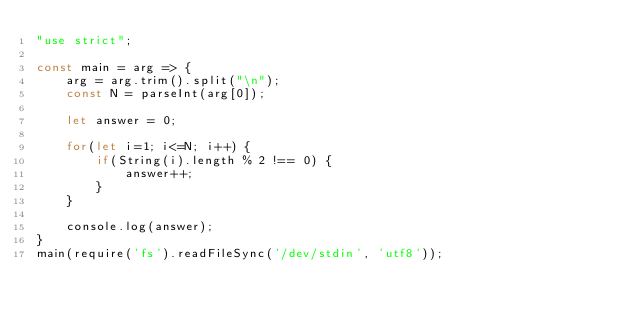<code> <loc_0><loc_0><loc_500><loc_500><_JavaScript_>"use strict";
    
const main = arg => {
    arg = arg.trim().split("\n");
    const N = parseInt(arg[0]);
    
    let answer = 0;
    
    for(let i=1; i<=N; i++) {
        if(String(i).length % 2 !== 0) {
            answer++;
        }
    }
    
    console.log(answer);
}
main(require('fs').readFileSync('/dev/stdin', 'utf8'));</code> 